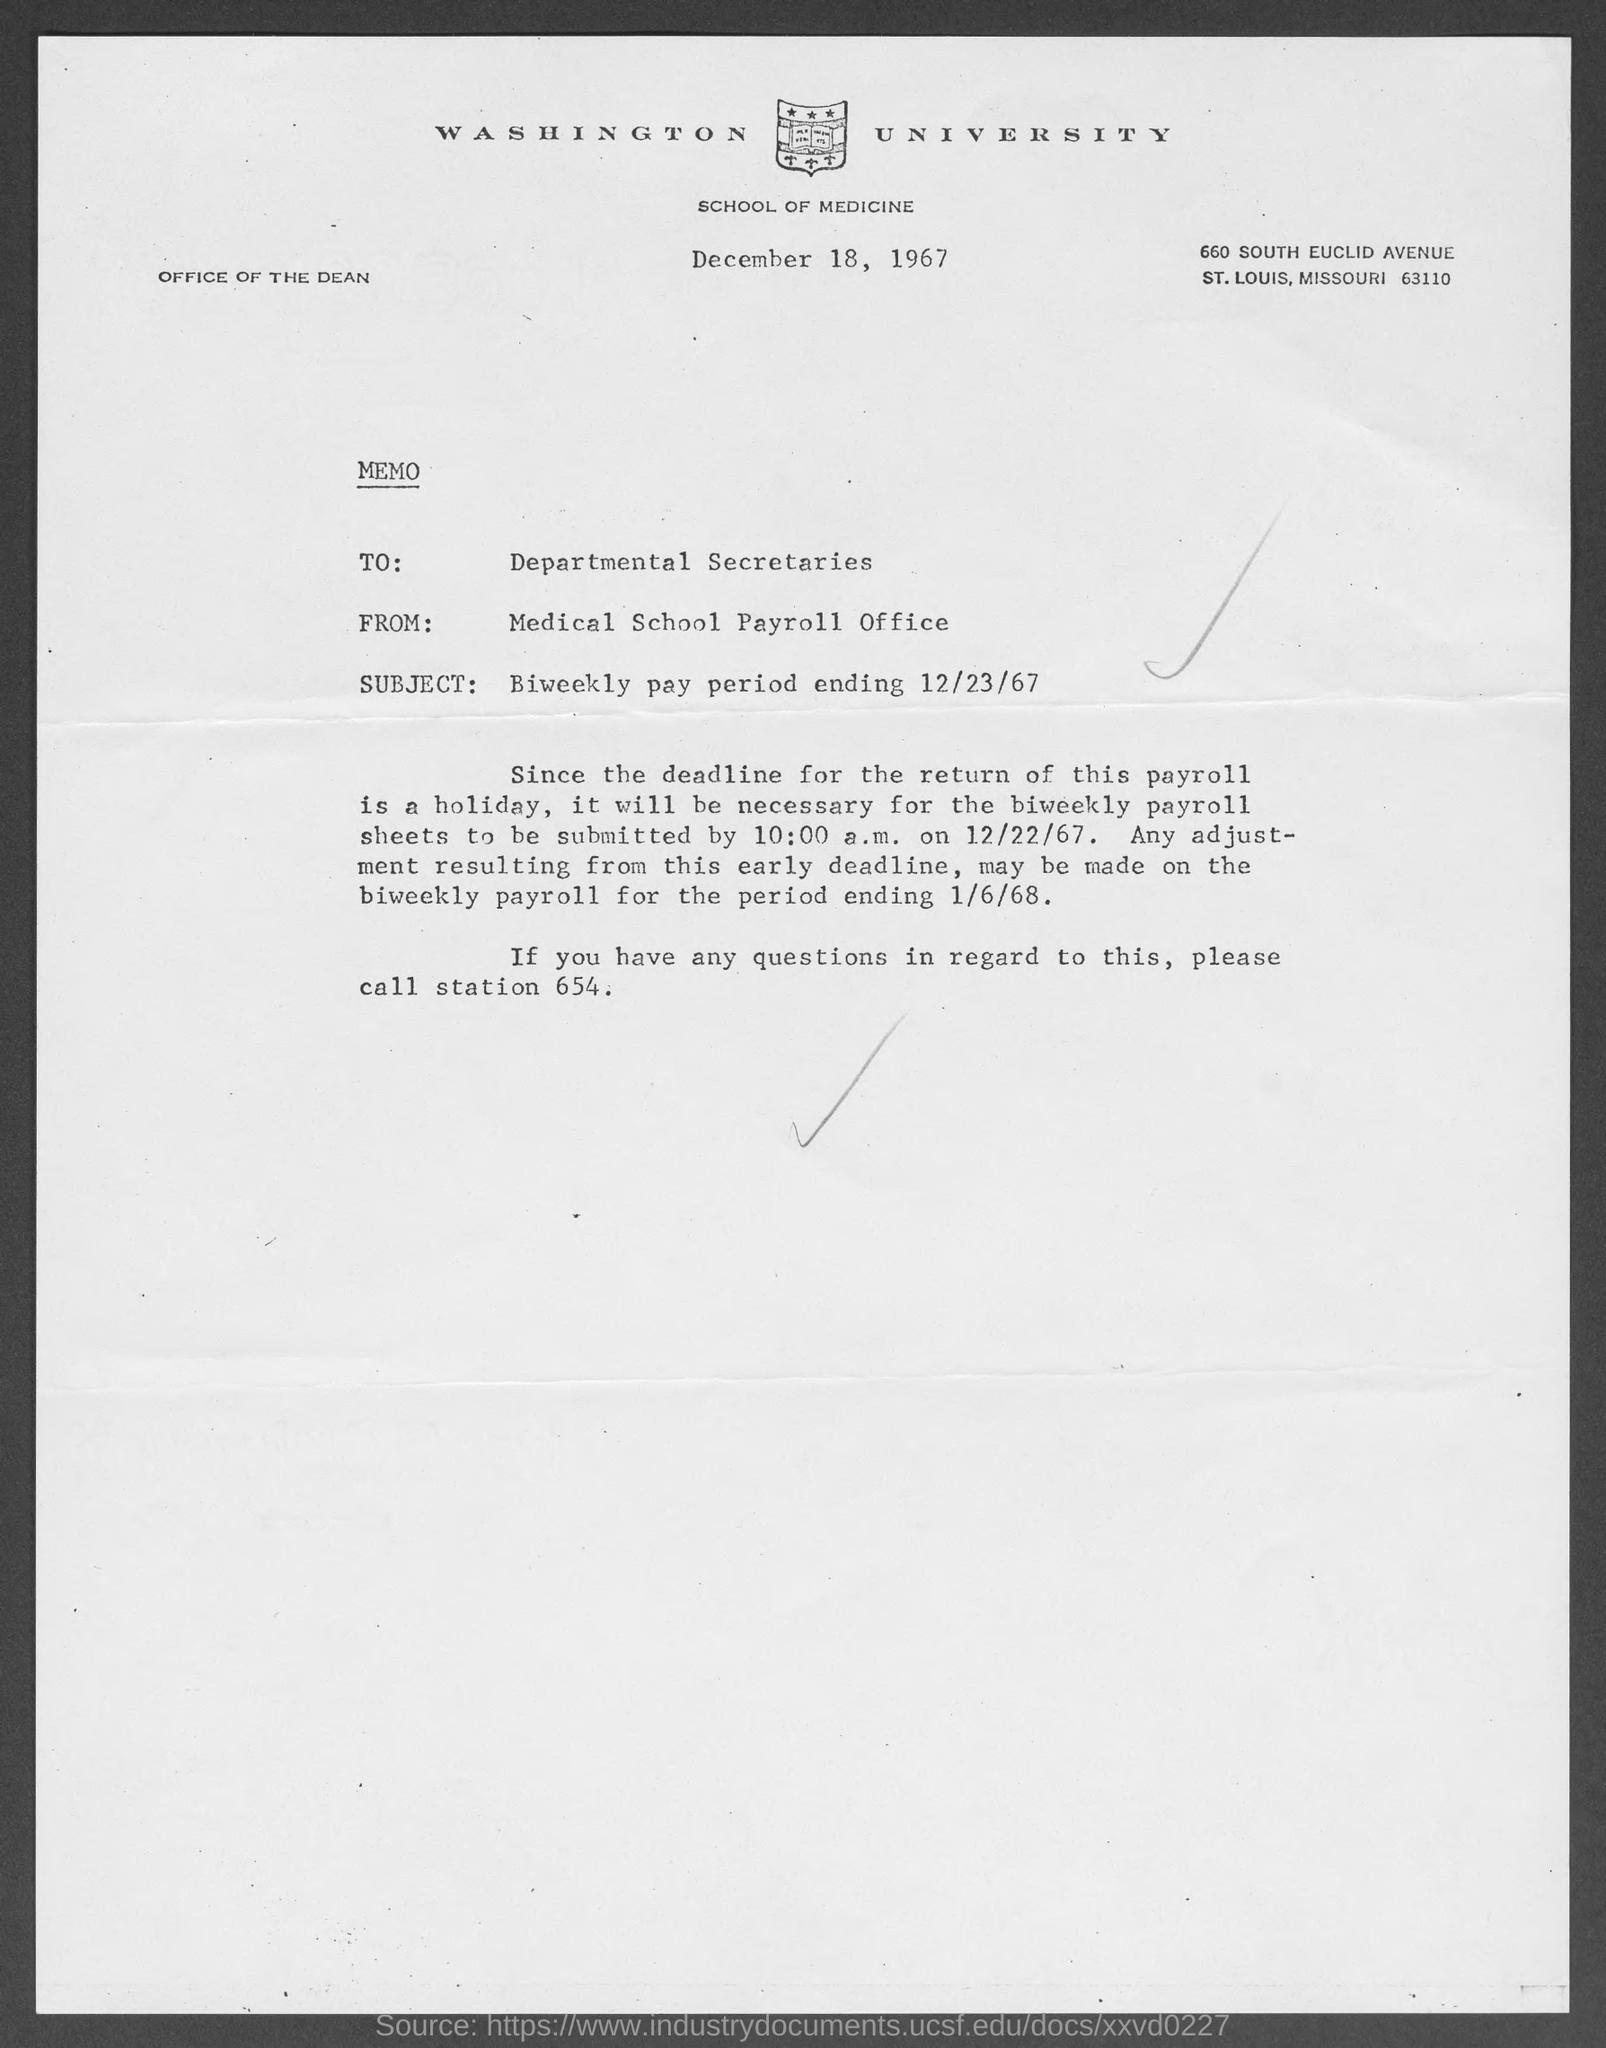Mention a couple of crucial points in this snapshot. The issued date of this memo is December 18, 1967. The memo is addressed to the Departmental Secretaries. The Medical School Payroll Office is the sender of this memo. The letter head mentions Washington University. The subject mentioned in the memo is the biweekly pay period ending on December 23, 1967. 